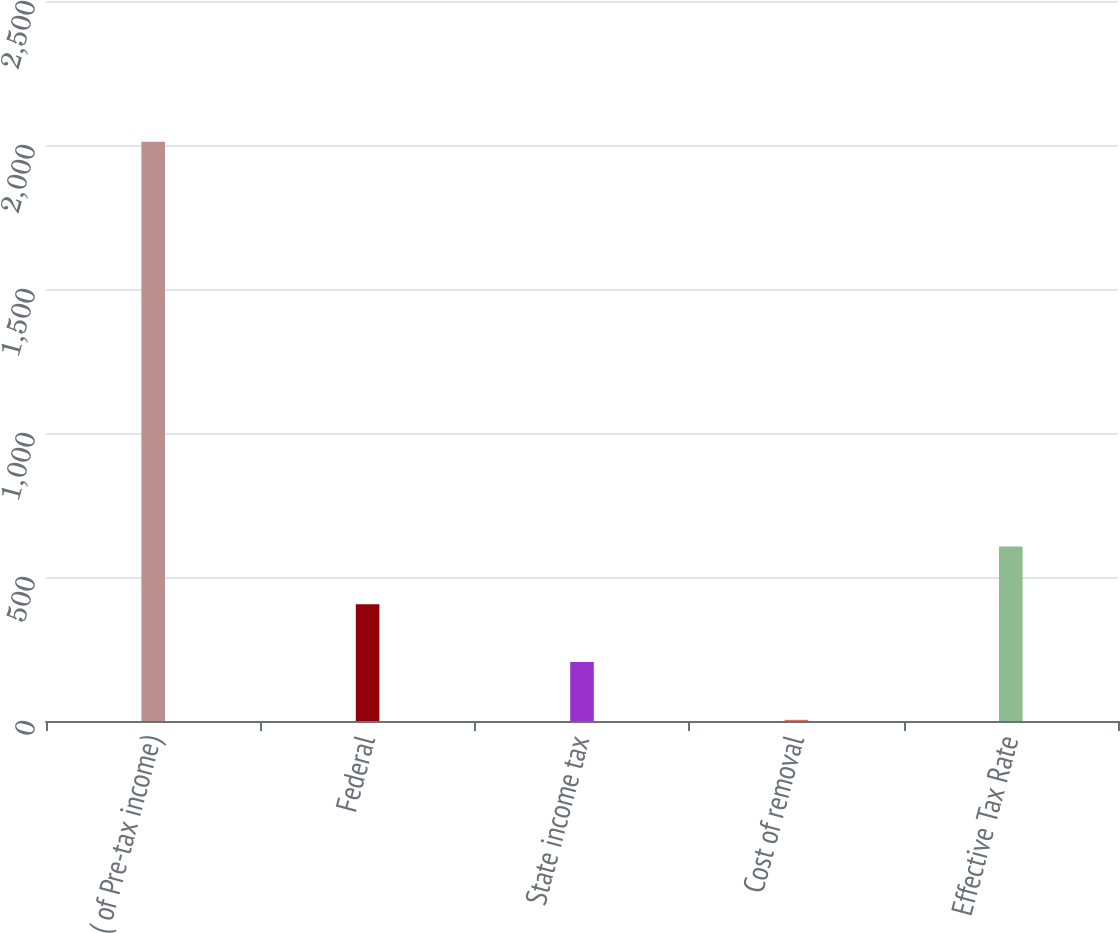<chart> <loc_0><loc_0><loc_500><loc_500><bar_chart><fcel>( of Pre-tax income)<fcel>Federal<fcel>State income tax<fcel>Cost of removal<fcel>Effective Tax Rate<nl><fcel>2011<fcel>405.4<fcel>204.7<fcel>4<fcel>606.1<nl></chart> 